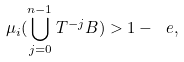<formula> <loc_0><loc_0><loc_500><loc_500>\mu _ { i } ( \bigcup _ { j = 0 } ^ { n - 1 } T ^ { - j } B ) > 1 - \ e ,</formula> 